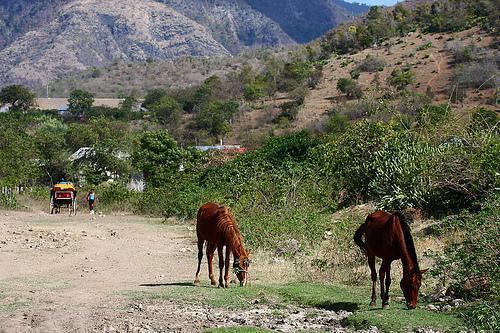How many horses are there?
Give a very brief answer. 2. How many carriages are there?
Give a very brief answer. 1. 